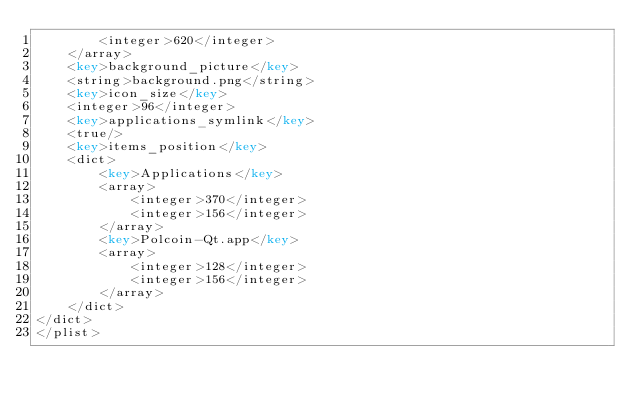Convert code to text. <code><loc_0><loc_0><loc_500><loc_500><_XML_>		<integer>620</integer>
	</array>
	<key>background_picture</key>
	<string>background.png</string>
	<key>icon_size</key>
	<integer>96</integer>
	<key>applications_symlink</key>
	<true/>
	<key>items_position</key>
	<dict>
		<key>Applications</key>
		<array>
			<integer>370</integer>
			<integer>156</integer>
		</array>
		<key>Polcoin-Qt.app</key>
		<array>
			<integer>128</integer>
			<integer>156</integer>
		</array>
	</dict>
</dict>
</plist>
</code> 